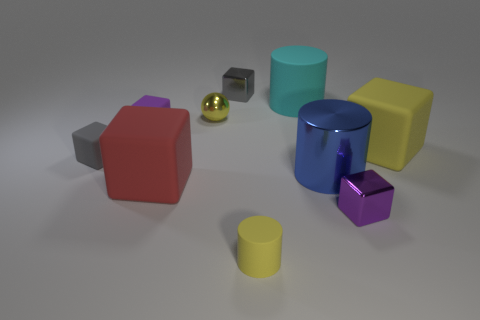Is there any other thing that is the same shape as the small yellow metallic thing?
Your answer should be very brief. No. There is a purple thing right of the tiny yellow cylinder; is there a matte block on the right side of it?
Your answer should be compact. Yes. What is the yellow ball made of?
Offer a very short reply. Metal. Are there any tiny rubber blocks right of the large blue shiny thing?
Your answer should be compact. No. What is the size of the cyan rubber thing that is the same shape as the blue object?
Your answer should be very brief. Large. Are there an equal number of small gray metal blocks that are to the right of the large blue cylinder and large red matte blocks to the left of the large yellow matte cube?
Offer a terse response. No. What number of gray rubber balls are there?
Your answer should be very brief. 0. Is the number of small shiny objects in front of the large cyan cylinder greater than the number of big cyan matte things?
Your answer should be compact. Yes. What material is the purple object in front of the red matte thing?
Provide a short and direct response. Metal. What is the color of the other big matte object that is the same shape as the large red thing?
Your answer should be compact. Yellow. 